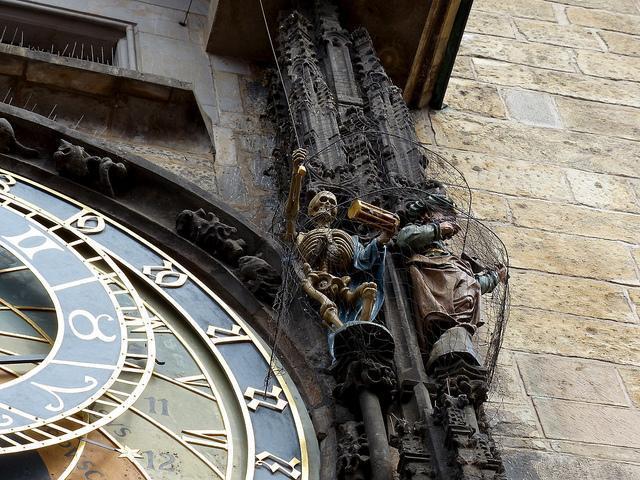How many donuts are on the plate?
Give a very brief answer. 0. 